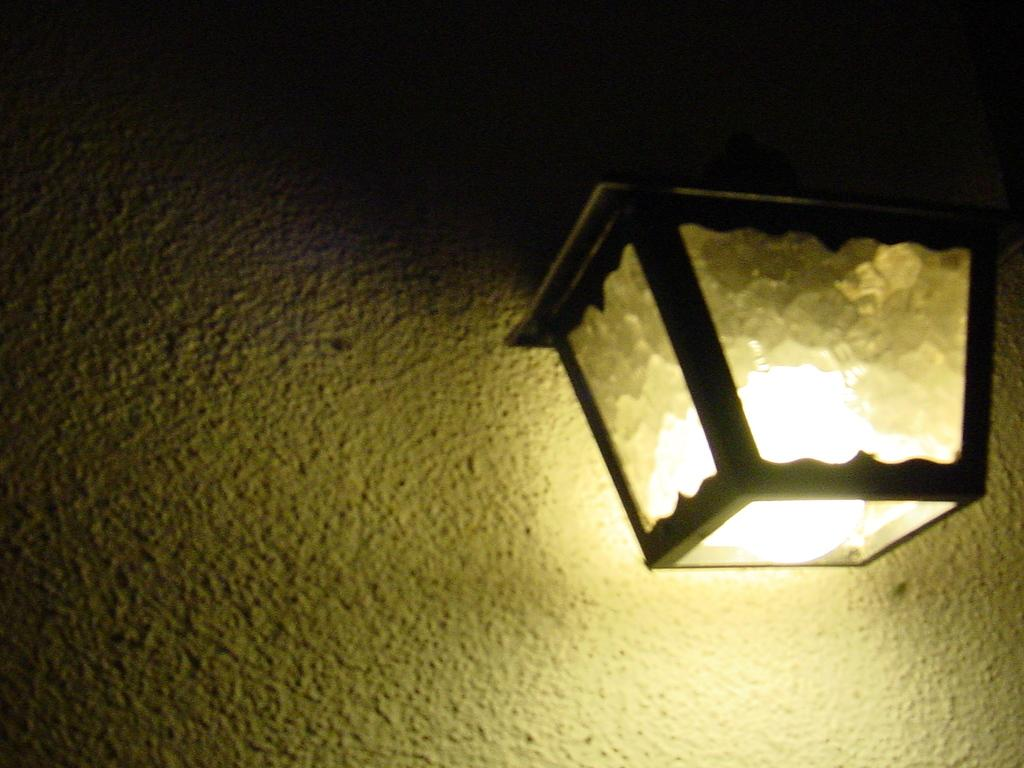What is the lighting condition in the image? The image was clicked in the dark. What object can be seen on the right side of the image? There is a lantern on the right side of the image. What is visible behind the lantern in the image? There is a wall visible at the back of the lantern in the image. Is there a gun visible in the image? No, there is no gun present in the image. What type of lock can be seen on the wall in the image? There is no lock visible on the wall in the image. 